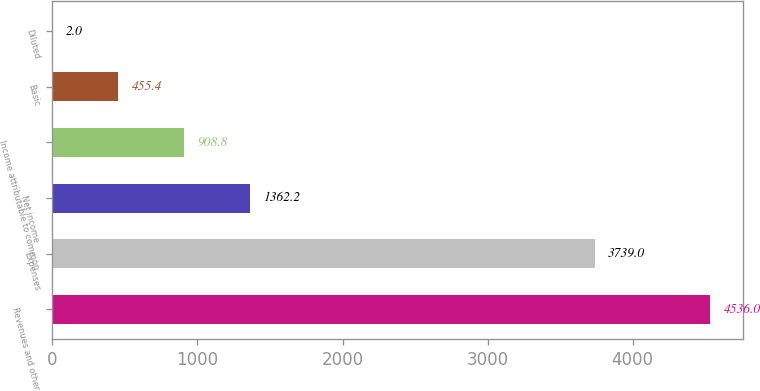Convert chart. <chart><loc_0><loc_0><loc_500><loc_500><bar_chart><fcel>Revenues and other<fcel>Expenses<fcel>Net income<fcel>Income attributable to common<fcel>Basic<fcel>Diluted<nl><fcel>4536<fcel>3739<fcel>1362.2<fcel>908.8<fcel>455.4<fcel>2<nl></chart> 